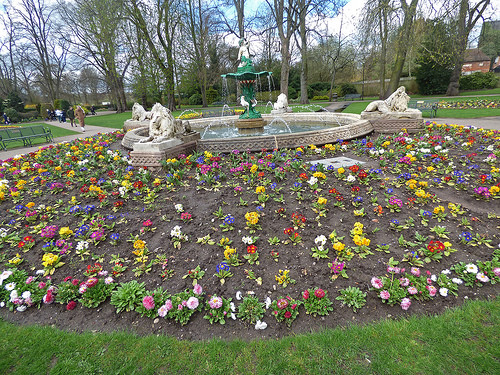<image>
Is there a flowers behind the grass? Yes. From this viewpoint, the flowers is positioned behind the grass, with the grass partially or fully occluding the flowers. 